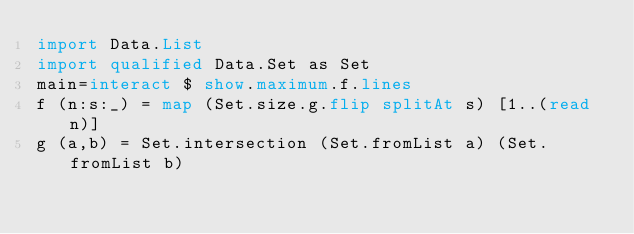<code> <loc_0><loc_0><loc_500><loc_500><_Haskell_>import Data.List
import qualified Data.Set as Set
main=interact $ show.maximum.f.lines
f (n:s:_) = map (Set.size.g.flip splitAt s) [1..(read n)]
g (a,b) = Set.intersection (Set.fromList a) (Set.fromList b)</code> 